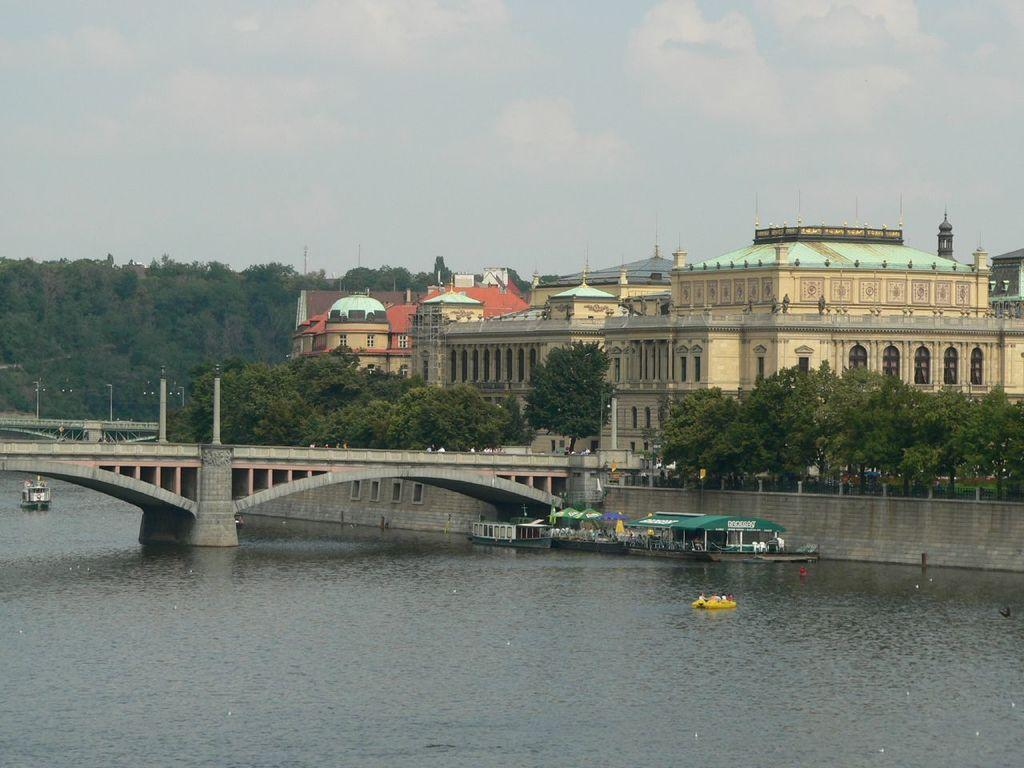What type of structure can be seen in the background of the image? There is a palace in the background of the image. What is located in front of the palace? Trees are present in front of the palace. What is in the middle of the image? There is a bridge in the middle of the image. What is the bridge over? The bridge is over a lake. What is in the lake? Ships are visible in the lake. What is visible in the sky? The sky is visible in the image. Can you see the face of the parent in the image? There is no face or parent present in the image. Did the earthquake cause any damage to the palace in the image? There is no mention of an earthquake or any damage in the image. 